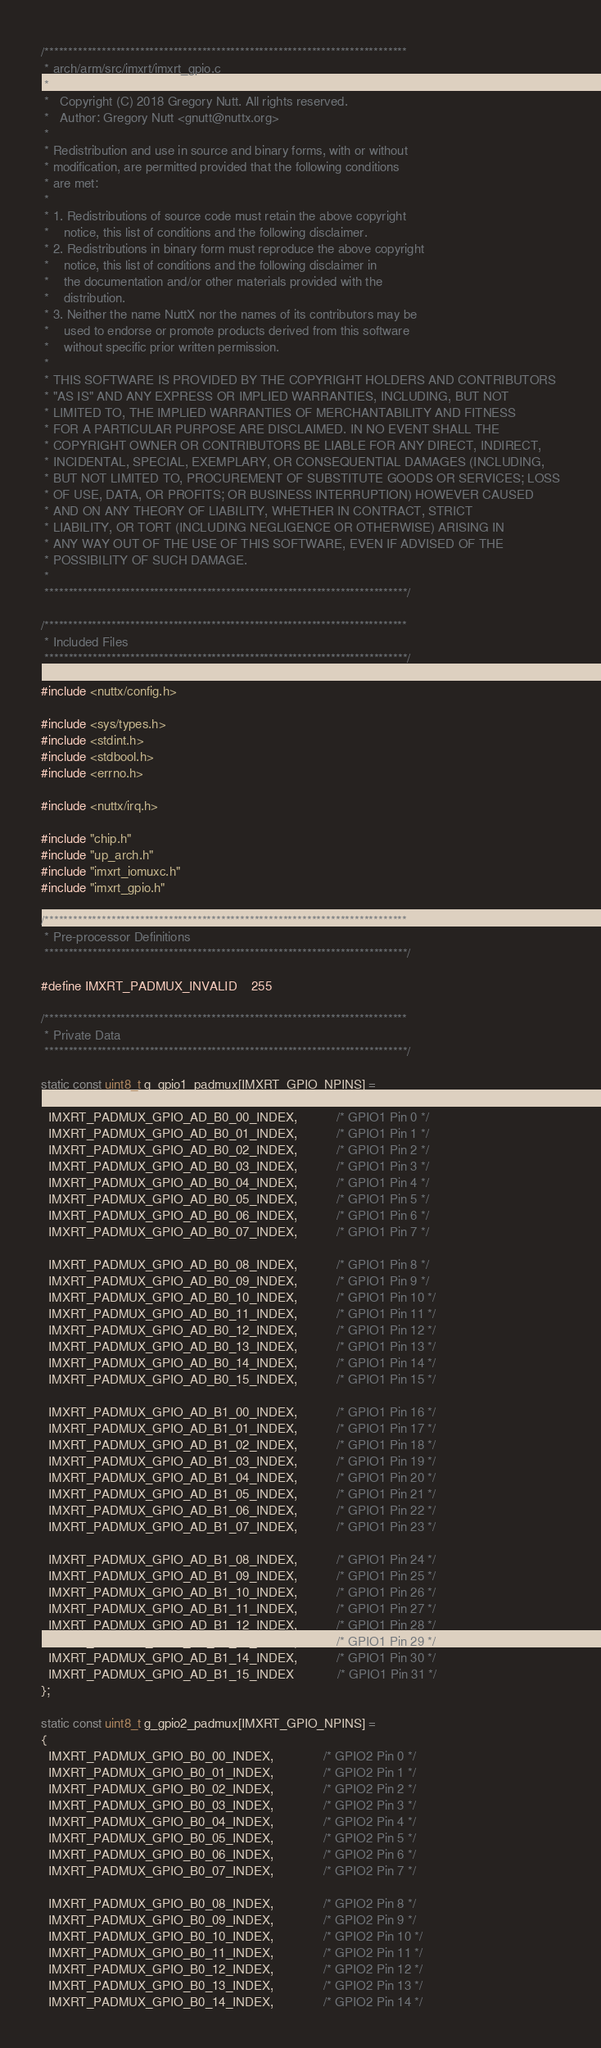<code> <loc_0><loc_0><loc_500><loc_500><_C_>/****************************************************************************
 * arch/arm/src/imxrt/imxrt_gpio.c
 *
 *   Copyright (C) 2018 Gregory Nutt. All rights reserved.
 *   Author: Gregory Nutt <gnutt@nuttx.org>
 *
 * Redistribution and use in source and binary forms, with or without
 * modification, are permitted provided that the following conditions
 * are met:
 *
 * 1. Redistributions of source code must retain the above copyright
 *    notice, this list of conditions and the following disclaimer.
 * 2. Redistributions in binary form must reproduce the above copyright
 *    notice, this list of conditions and the following disclaimer in
 *    the documentation and/or other materials provided with the
 *    distribution.
 * 3. Neither the name NuttX nor the names of its contributors may be
 *    used to endorse or promote products derived from this software
 *    without specific prior written permission.
 *
 * THIS SOFTWARE IS PROVIDED BY THE COPYRIGHT HOLDERS AND CONTRIBUTORS
 * "AS IS" AND ANY EXPRESS OR IMPLIED WARRANTIES, INCLUDING, BUT NOT
 * LIMITED TO, THE IMPLIED WARRANTIES OF MERCHANTABILITY AND FITNESS
 * FOR A PARTICULAR PURPOSE ARE DISCLAIMED. IN NO EVENT SHALL THE
 * COPYRIGHT OWNER OR CONTRIBUTORS BE LIABLE FOR ANY DIRECT, INDIRECT,
 * INCIDENTAL, SPECIAL, EXEMPLARY, OR CONSEQUENTIAL DAMAGES (INCLUDING,
 * BUT NOT LIMITED TO, PROCUREMENT OF SUBSTITUTE GOODS OR SERVICES; LOSS
 * OF USE, DATA, OR PROFITS; OR BUSINESS INTERRUPTION) HOWEVER CAUSED
 * AND ON ANY THEORY OF LIABILITY, WHETHER IN CONTRACT, STRICT
 * LIABILITY, OR TORT (INCLUDING NEGLIGENCE OR OTHERWISE) ARISING IN
 * ANY WAY OUT OF THE USE OF THIS SOFTWARE, EVEN IF ADVISED OF THE
 * POSSIBILITY OF SUCH DAMAGE.
 *
 ****************************************************************************/

/****************************************************************************
 * Included Files
 ****************************************************************************/

#include <nuttx/config.h>

#include <sys/types.h>
#include <stdint.h>
#include <stdbool.h>
#include <errno.h>

#include <nuttx/irq.h>

#include "chip.h"
#include "up_arch.h"
#include "imxrt_iomuxc.h"
#include "imxrt_gpio.h"

/****************************************************************************
 * Pre-processor Definitions
 ****************************************************************************/

#define IMXRT_PADMUX_INVALID    255

/****************************************************************************
 * Private Data
 ****************************************************************************/

static const uint8_t g_gpio1_padmux[IMXRT_GPIO_NPINS] =
{
  IMXRT_PADMUX_GPIO_AD_B0_00_INDEX,           /* GPIO1 Pin 0 */
  IMXRT_PADMUX_GPIO_AD_B0_01_INDEX,           /* GPIO1 Pin 1 */
  IMXRT_PADMUX_GPIO_AD_B0_02_INDEX,           /* GPIO1 Pin 2 */
  IMXRT_PADMUX_GPIO_AD_B0_03_INDEX,           /* GPIO1 Pin 3 */
  IMXRT_PADMUX_GPIO_AD_B0_04_INDEX,           /* GPIO1 Pin 4 */
  IMXRT_PADMUX_GPIO_AD_B0_05_INDEX,           /* GPIO1 Pin 5 */
  IMXRT_PADMUX_GPIO_AD_B0_06_INDEX,           /* GPIO1 Pin 6 */
  IMXRT_PADMUX_GPIO_AD_B0_07_INDEX,           /* GPIO1 Pin 7 */

  IMXRT_PADMUX_GPIO_AD_B0_08_INDEX,           /* GPIO1 Pin 8 */
  IMXRT_PADMUX_GPIO_AD_B0_09_INDEX,           /* GPIO1 Pin 9 */
  IMXRT_PADMUX_GPIO_AD_B0_10_INDEX,           /* GPIO1 Pin 10 */
  IMXRT_PADMUX_GPIO_AD_B0_11_INDEX,           /* GPIO1 Pin 11 */
  IMXRT_PADMUX_GPIO_AD_B0_12_INDEX,           /* GPIO1 Pin 12 */
  IMXRT_PADMUX_GPIO_AD_B0_13_INDEX,           /* GPIO1 Pin 13 */
  IMXRT_PADMUX_GPIO_AD_B0_14_INDEX,           /* GPIO1 Pin 14 */
  IMXRT_PADMUX_GPIO_AD_B0_15_INDEX,           /* GPIO1 Pin 15 */

  IMXRT_PADMUX_GPIO_AD_B1_00_INDEX,           /* GPIO1 Pin 16 */
  IMXRT_PADMUX_GPIO_AD_B1_01_INDEX,           /* GPIO1 Pin 17 */
  IMXRT_PADMUX_GPIO_AD_B1_02_INDEX,           /* GPIO1 Pin 18 */
  IMXRT_PADMUX_GPIO_AD_B1_03_INDEX,           /* GPIO1 Pin 19 */
  IMXRT_PADMUX_GPIO_AD_B1_04_INDEX,           /* GPIO1 Pin 20 */
  IMXRT_PADMUX_GPIO_AD_B1_05_INDEX,           /* GPIO1 Pin 21 */
  IMXRT_PADMUX_GPIO_AD_B1_06_INDEX,           /* GPIO1 Pin 22 */
  IMXRT_PADMUX_GPIO_AD_B1_07_INDEX,           /* GPIO1 Pin 23 */

  IMXRT_PADMUX_GPIO_AD_B1_08_INDEX,           /* GPIO1 Pin 24 */
  IMXRT_PADMUX_GPIO_AD_B1_09_INDEX,           /* GPIO1 Pin 25 */
  IMXRT_PADMUX_GPIO_AD_B1_10_INDEX,           /* GPIO1 Pin 26 */
  IMXRT_PADMUX_GPIO_AD_B1_11_INDEX,           /* GPIO1 Pin 27 */
  IMXRT_PADMUX_GPIO_AD_B1_12_INDEX,           /* GPIO1 Pin 28 */
  IMXRT_PADMUX_GPIO_AD_B1_13_INDEX,           /* GPIO1 Pin 29 */
  IMXRT_PADMUX_GPIO_AD_B1_14_INDEX,           /* GPIO1 Pin 30 */
  IMXRT_PADMUX_GPIO_AD_B1_15_INDEX            /* GPIO1 Pin 31 */
};

static const uint8_t g_gpio2_padmux[IMXRT_GPIO_NPINS] =
{
  IMXRT_PADMUX_GPIO_B0_00_INDEX,              /* GPIO2 Pin 0 */
  IMXRT_PADMUX_GPIO_B0_01_INDEX,              /* GPIO2 Pin 1 */
  IMXRT_PADMUX_GPIO_B0_02_INDEX,              /* GPIO2 Pin 2 */
  IMXRT_PADMUX_GPIO_B0_03_INDEX,              /* GPIO2 Pin 3 */
  IMXRT_PADMUX_GPIO_B0_04_INDEX,              /* GPIO2 Pin 4 */
  IMXRT_PADMUX_GPIO_B0_05_INDEX,              /* GPIO2 Pin 5 */
  IMXRT_PADMUX_GPIO_B0_06_INDEX,              /* GPIO2 Pin 6 */
  IMXRT_PADMUX_GPIO_B0_07_INDEX,              /* GPIO2 Pin 7 */

  IMXRT_PADMUX_GPIO_B0_08_INDEX,              /* GPIO2 Pin 8 */
  IMXRT_PADMUX_GPIO_B0_09_INDEX,              /* GPIO2 Pin 9 */
  IMXRT_PADMUX_GPIO_B0_10_INDEX,              /* GPIO2 Pin 10 */
  IMXRT_PADMUX_GPIO_B0_11_INDEX,              /* GPIO2 Pin 11 */
  IMXRT_PADMUX_GPIO_B0_12_INDEX,              /* GPIO2 Pin 12 */
  IMXRT_PADMUX_GPIO_B0_13_INDEX,              /* GPIO2 Pin 13 */
  IMXRT_PADMUX_GPIO_B0_14_INDEX,              /* GPIO2 Pin 14 */</code> 